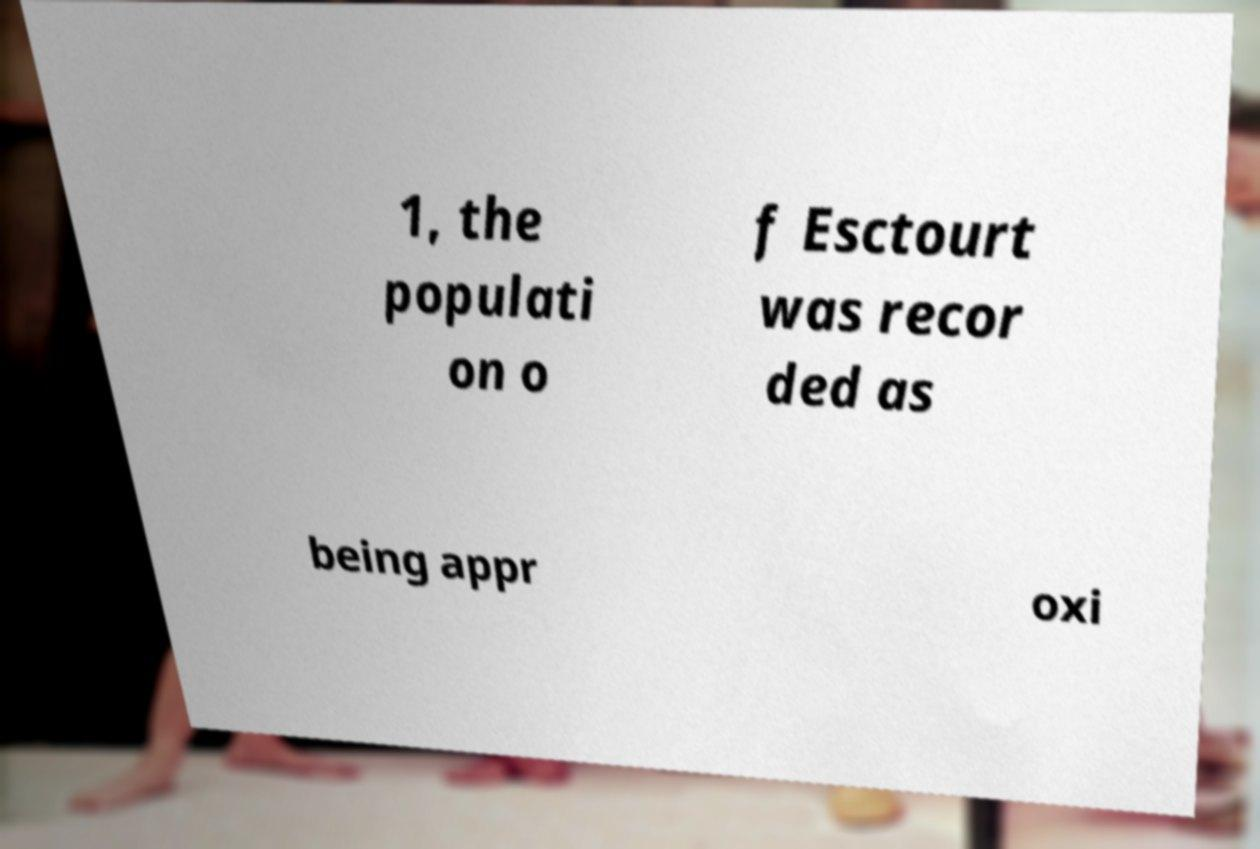Please read and relay the text visible in this image. What does it say? 1, the populati on o f Esctourt was recor ded as being appr oxi 